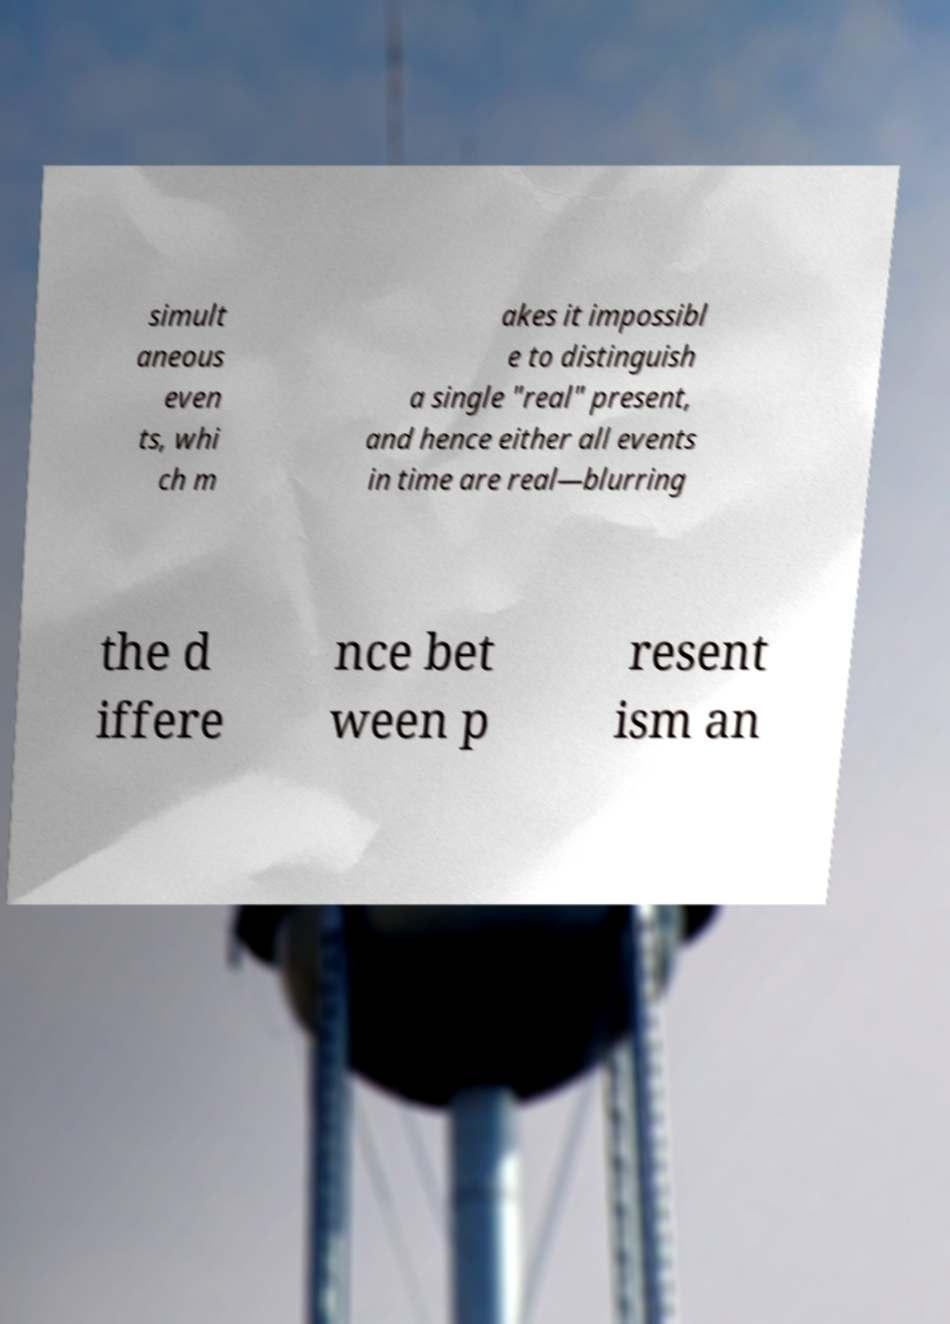Can you read and provide the text displayed in the image?This photo seems to have some interesting text. Can you extract and type it out for me? simult aneous even ts, whi ch m akes it impossibl e to distinguish a single "real" present, and hence either all events in time are real—blurring the d iffere nce bet ween p resent ism an 